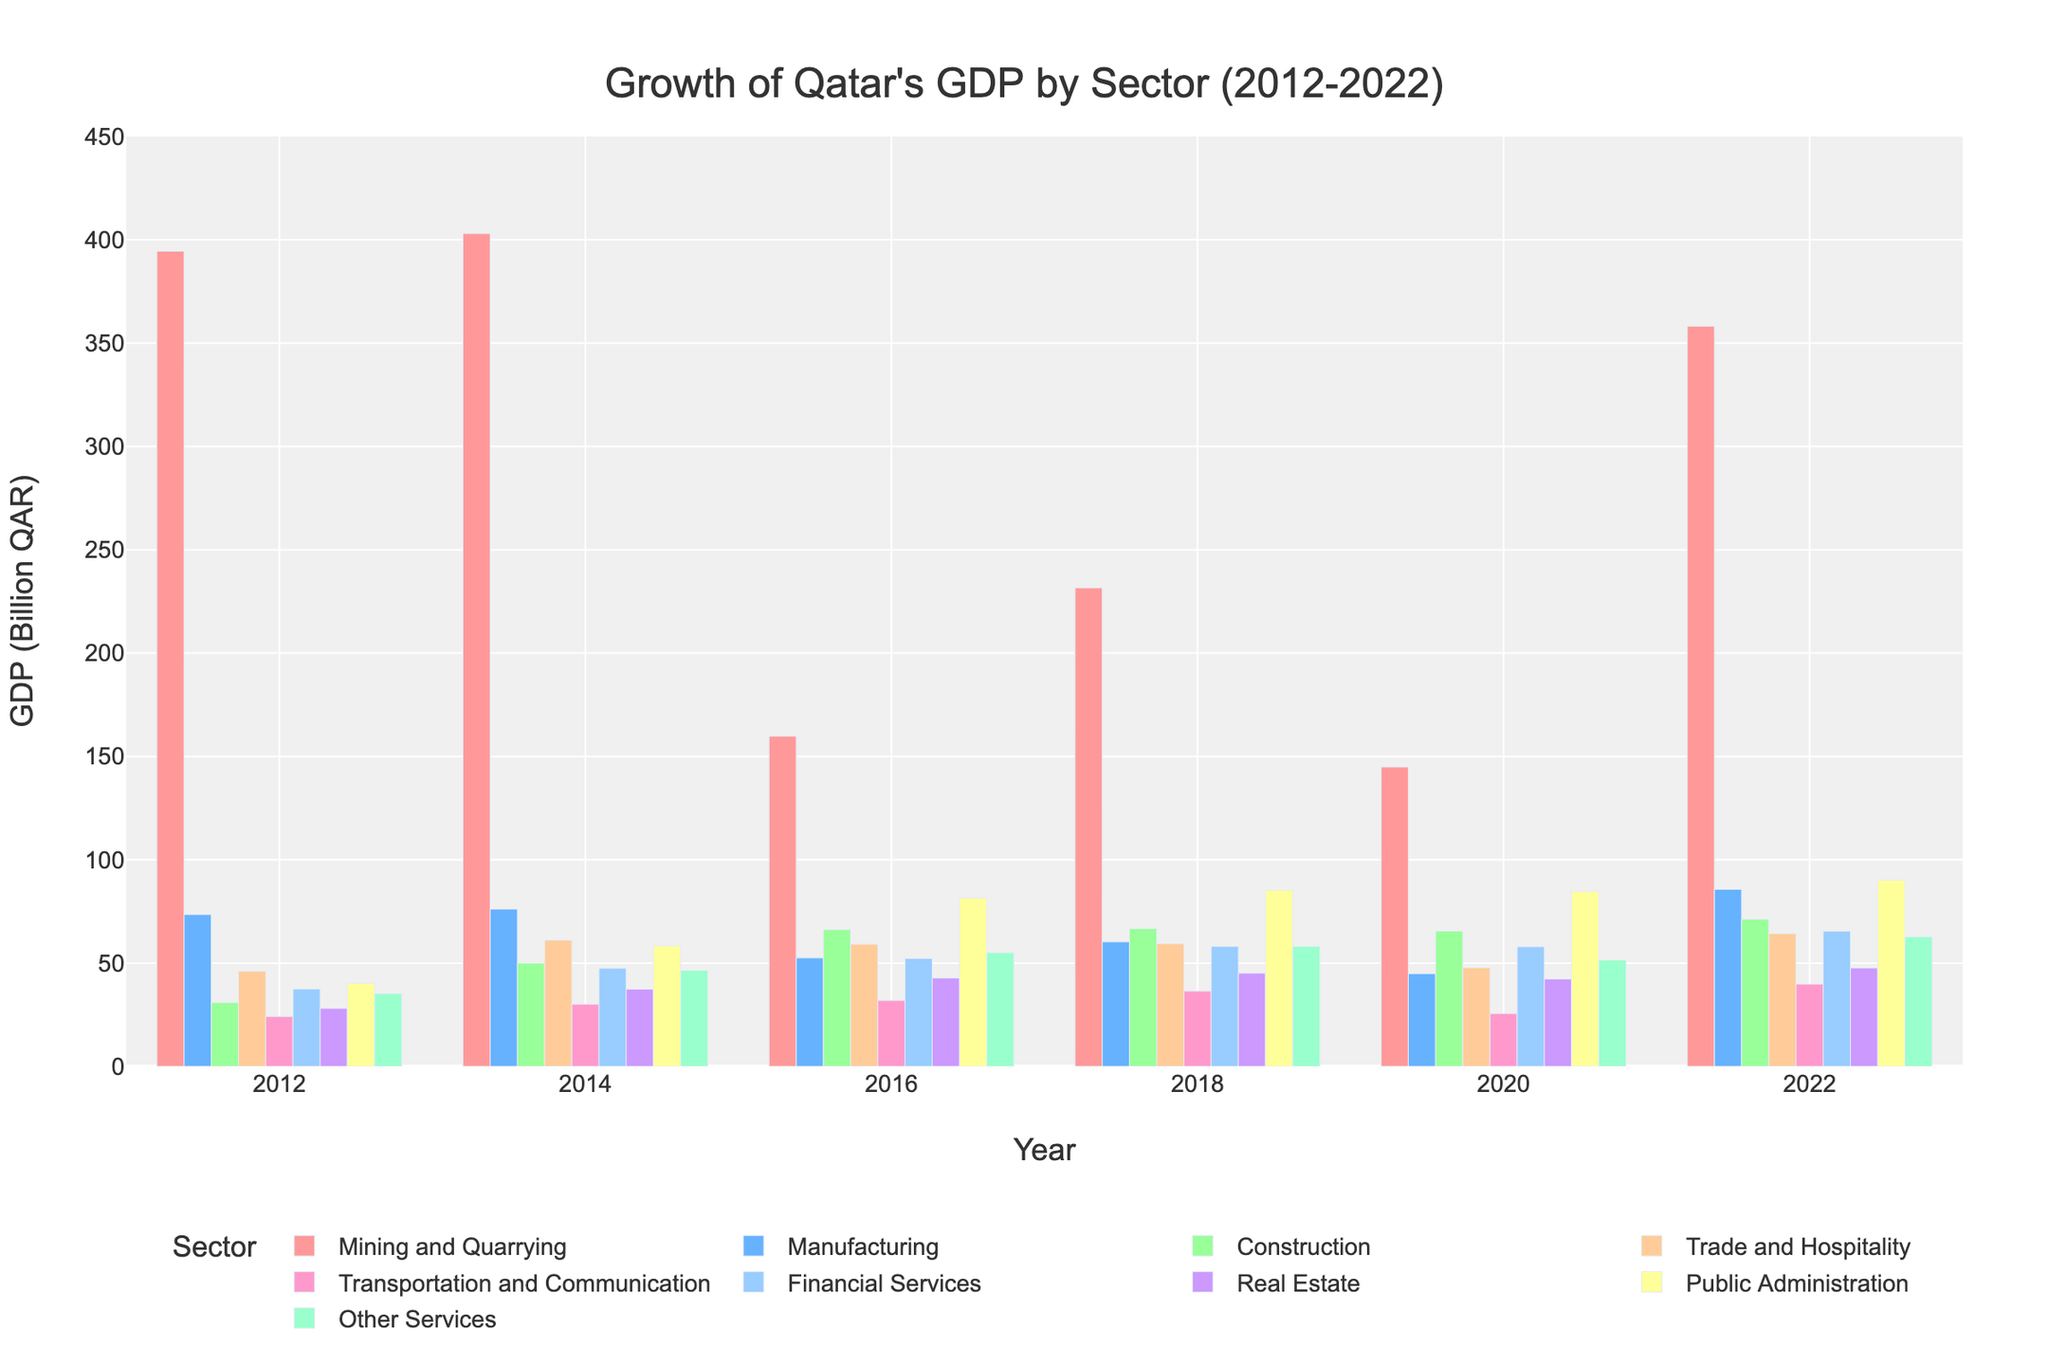Which sector shows the highest growth in GDP from 2012 to 2022? To identify the sector with the highest growth, we need to look at the bars representing 2012 and 2022 for each sector and find the largest difference between these two years. Mining and Quarrying shows a significant increase from 394.5 billion QAR in 2012 to 358.2 billion QAR in 2022.
Answer: Mining and Quarrying Which sector had the lowest GDP in 2012 compared to the other sectors? We compare the heights of the bars for each sector for the year 2012. The bar representing Transportation and Communication is the shortest in 2012, indicating the lowest GDP at 24.1 billion QAR.
Answer: Transportation and Communication Compare the GDP of Construction and Real Estate sectors in 2022. Which one is higher, and by how much? Compare the heights of the bars for Construction and Real Estate in 2022. Construction has a GDP of 71.2 billion QAR, while Real Estate has 47.6 billion QAR. The difference is 71.2 - 47.6 = 23.6 billion QAR.
Answer: Construction by 23.6 billion QAR What's the average GDP for the Financial Services sector across all given years? Add the GDP values for Financial Services from 2012, 2014, 2016, 2018, 2020, and 2022, then divide by the number of years. (37.5 + 47.5 + 52.2 + 58.1 + 57.9 + 65.4) / 6 = 53.1
Answer: 53.1 billion QAR In which year does the Trade and Hospitality sector experience the biggest drop in GDP? Look at the sequential bars for Trade and Hospitality and observe the differences year by year. The biggest drop is from 61.1 billion QAR in 2014 to 59.1 billion QAR in 2016, a decrease of 2 billion QAR.
Answer: 2014 to 2016 How does the GDP of Other Services in 2020 compare to its GDP in 2018? Calculate the difference: 51.5 billion QAR in 2020 minus 58.1 billion QAR in 2018. This results in a decrease.
Answer: Decreased by 6.6 billion QAR What's the combined GDP of Manufacturing and Financial Services in 2016? Sum the GDP values of Manufacturing and Financial Services in 2016. Manufacturing: 52.5 + Financial Services: 52.2 = 104.7 billion QAR.
Answer: 104.7 billion QAR Which sector experienced a growth in GDP every year from 2012 to 2022? Analyze the GDP values year by year for each sector to find any sector that shows a constant increase. Public Administration grows every year from 40.2 billion QAR in 2012 to 90.1 billion QAR in 2022.
Answer: Public Administration Between 2012 and 2022, which year saw the highest GDP in the Manufacturing sector? Look for the tallest bar within the Manufacturing sector across all years. The highest GDP for Manufacturing is in 2022 at 85.7 billion QAR.
Answer: 2022 What is the total GDP of the Transportation and Communication sector over the last decade (2012-2022)? Sum the GDP values of the Transportation and Communication sector for all years: 24.1 + 30.1 + 31.9 + 36.4 + 25.6 + 39.8 = 187.9 billion QAR.
Answer: 187.9 billion QAR 